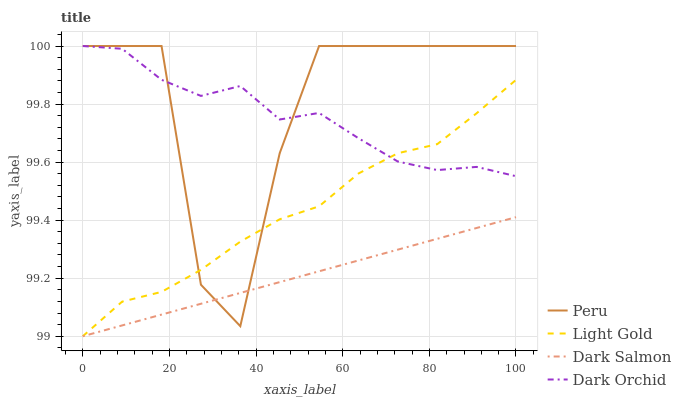Does Dark Salmon have the minimum area under the curve?
Answer yes or no. Yes. Does Peru have the maximum area under the curve?
Answer yes or no. Yes. Does Light Gold have the minimum area under the curve?
Answer yes or no. No. Does Light Gold have the maximum area under the curve?
Answer yes or no. No. Is Dark Salmon the smoothest?
Answer yes or no. Yes. Is Peru the roughest?
Answer yes or no. Yes. Is Light Gold the smoothest?
Answer yes or no. No. Is Light Gold the roughest?
Answer yes or no. No. Does Light Gold have the lowest value?
Answer yes or no. Yes. Does Peru have the lowest value?
Answer yes or no. No. Does Peru have the highest value?
Answer yes or no. Yes. Does Light Gold have the highest value?
Answer yes or no. No. Is Dark Salmon less than Dark Orchid?
Answer yes or no. Yes. Is Dark Orchid greater than Dark Salmon?
Answer yes or no. Yes. Does Dark Salmon intersect Light Gold?
Answer yes or no. Yes. Is Dark Salmon less than Light Gold?
Answer yes or no. No. Is Dark Salmon greater than Light Gold?
Answer yes or no. No. Does Dark Salmon intersect Dark Orchid?
Answer yes or no. No. 